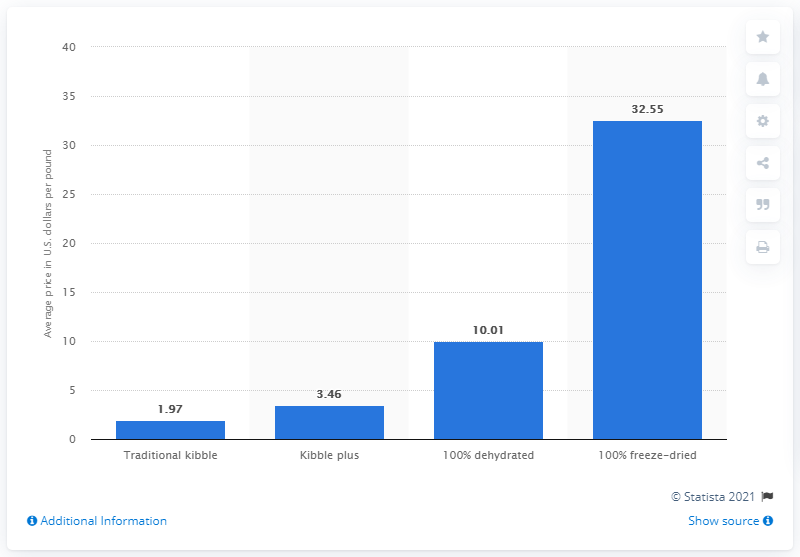Identify some key points in this picture. In 2019, the cost of traditional kibble per pound was 1.97 dollars. In 2019, the average cost per pound of 100% freeze dried kibble in the United States was $32.55. 